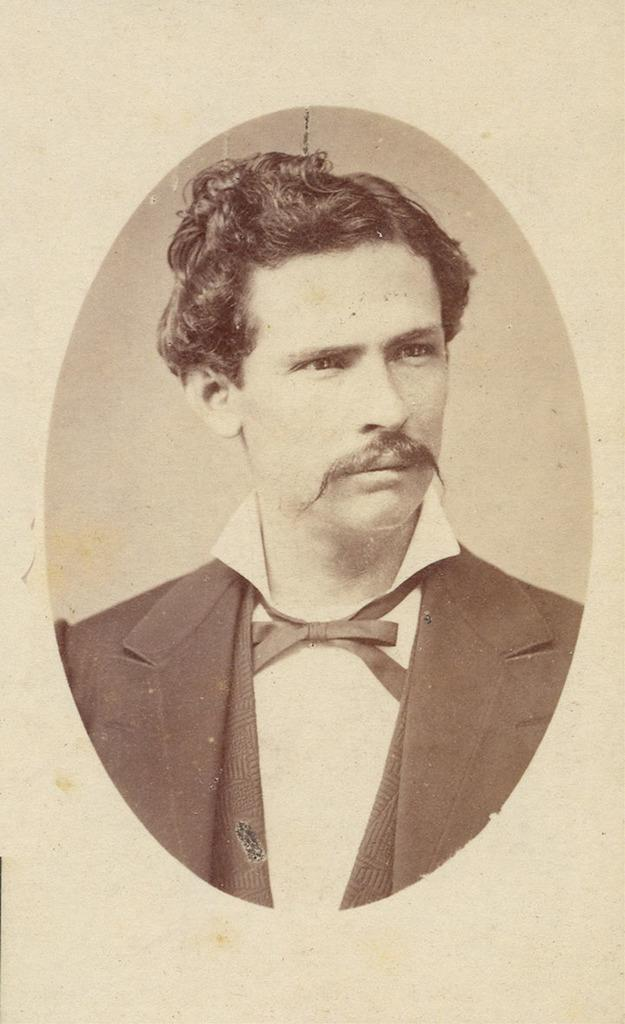What type of picture is shown in the image? The image is an old black and white picture. Who or what is the main subject of the picture? The picture depicts a man. What is the man wearing in the image? The man is wearing a shirt and a suit. Where is the badge located on the man in the image? There is no badge visible on the man in the image. What type of jar can be seen on the shelf behind the man in the image? There is no shelf or jar present in the image; it only shows a man wearing a shirt and a suit. 